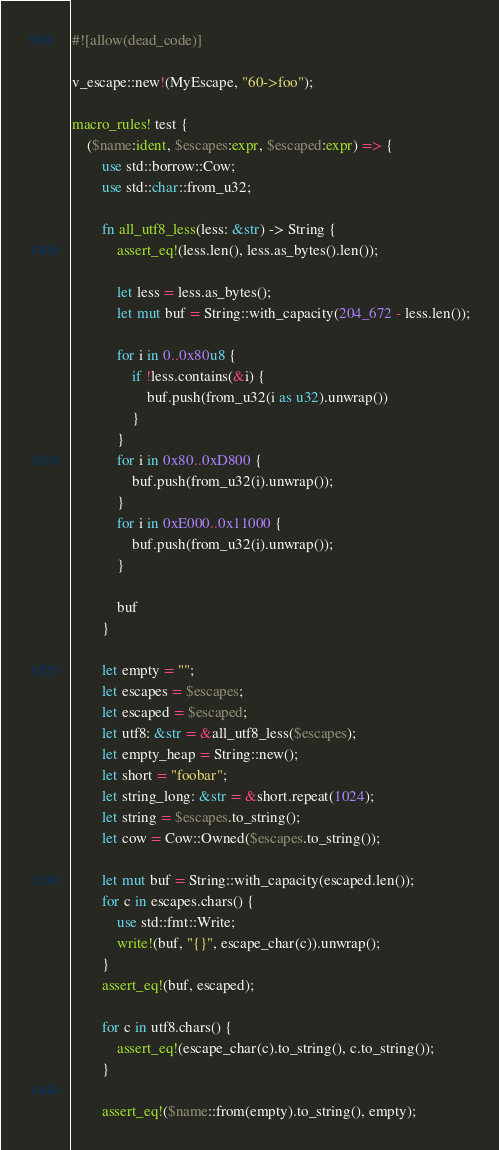Convert code to text. <code><loc_0><loc_0><loc_500><loc_500><_Rust_>#![allow(dead_code)]

v_escape::new!(MyEscape, "60->foo");

macro_rules! test {
    ($name:ident, $escapes:expr, $escaped:expr) => {
        use std::borrow::Cow;
        use std::char::from_u32;

        fn all_utf8_less(less: &str) -> String {
            assert_eq!(less.len(), less.as_bytes().len());

            let less = less.as_bytes();
            let mut buf = String::with_capacity(204_672 - less.len());

            for i in 0..0x80u8 {
                if !less.contains(&i) {
                    buf.push(from_u32(i as u32).unwrap())
                }
            }
            for i in 0x80..0xD800 {
                buf.push(from_u32(i).unwrap());
            }
            for i in 0xE000..0x11000 {
                buf.push(from_u32(i).unwrap());
            }

            buf
        }

        let empty = "";
        let escapes = $escapes;
        let escaped = $escaped;
        let utf8: &str = &all_utf8_less($escapes);
        let empty_heap = String::new();
        let short = "foobar";
        let string_long: &str = &short.repeat(1024);
        let string = $escapes.to_string();
        let cow = Cow::Owned($escapes.to_string());

        let mut buf = String::with_capacity(escaped.len());
        for c in escapes.chars() {
            use std::fmt::Write;
            write!(buf, "{}", escape_char(c)).unwrap();
        }
        assert_eq!(buf, escaped);

        for c in utf8.chars() {
            assert_eq!(escape_char(c).to_string(), c.to_string());
        }

        assert_eq!($name::from(empty).to_string(), empty);</code> 